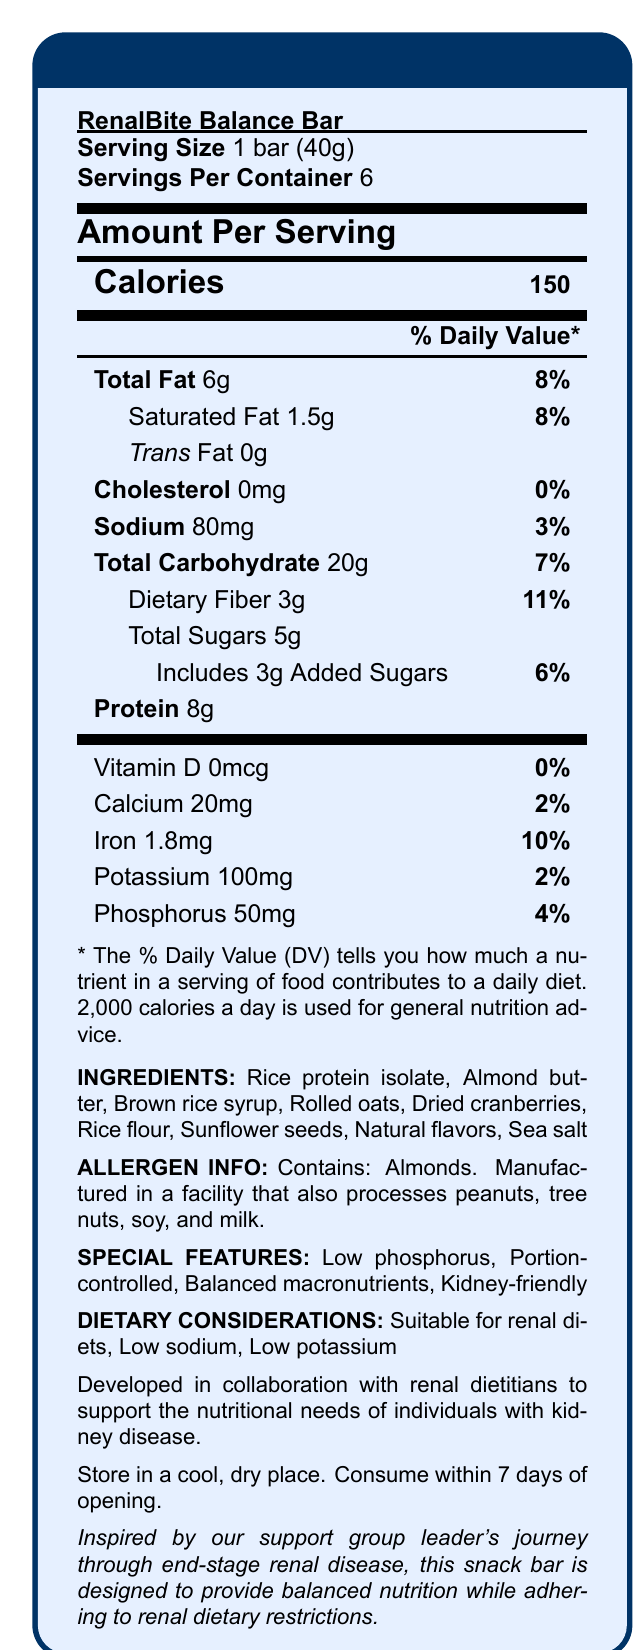what is the serving size of the RenalBite Balance Bar? The serving size is mentioned directly under the product name within the "Nutrition Facts" box.
Answer: 1 bar (40g) how many calories are in one serving of the RenalBite Balance Bar? The calories per serving are listed in bold under "Amount Per Serving."
Answer: 150 what percentage of the Daily Value is the total fat content in one serving? The Daily Value percentage for Total Fat is indicated alongside the amount of total fat.
Answer: 8% how much protein does one serving contain? The protein content is mentioned in the nutritional information section as "Protein 8g."
Answer: 8g which ingredient might cause an allergic reaction in someone with nut allergies? The Allergen Info section states the bar contains almonds.
Answer: Almonds how much sodium is present in one serving? The amount of sodium is listed in the nutrient table.
Answer: 80mg what is the source of dietary fiber in the ingredients list? A. Almond butter B. Rolled oats C. Dried cranberries D. Rice protein isolate While dietary fiber can come from multiple ingredients, rolled oats is a common high-fiber ingredient.
Answer: B. Rolled oats what is the daily value percentage of iron in one serving of the snack bar? A. 2% B. 10% C. 5% D. 15% The Daily Value percentage for iron is given as 10%.
Answer: B. 10% is the RenalBite Balance Bar suitable for renal diets? The document mentions that the bar is suitable for renal diets under "Dietary Considerations."
Answer: Yes does the product contain any trans fat? The amount of trans fat is listed as "Trans Fat 0g."
Answer: No / 0g summarize the main features of the RenalBite Balance Bar. The document details the nutritional content, ingredients, allergen information, and special features of the RenalBite Balance Bar, highlighting its suitability for renal diets.
Answer: The RenalBite Balance Bar is a snack specifically designed to support renal health. It is portion-controlled, low in phosphorus, sodium, and potassium, and provides balanced macronutrients. Developed in collaboration with renal dietitians, it aims to meet the dietary needs of individuals with kidney disease. what is the storage instruction for the RenalBite Balance Bar once opened? The storage instructions are listed at the end of the document.
Answer: Store in a cool, dry place. Consume within 7 days of opening. how many servings are there in one container of the snack bar? The number of servings per container is explicitly mentioned.
Answer: 6 does the RenalBite Balance Bar contain any vitamin D? The amount of vitamin D is given as 0mcg, which means the bar contains no vitamin D.
Answer: No what is the phosphorus content per serving? The phosphorus content is listed in the nutrient section as "Phosphorus 50mg."
Answer: 50mg who collaborated to develop the RenalBite Balance Bar? The manufacturer statement explicitly mentions the collaboration with renal dietitians.
Answer: Renal dietitians who inspired the development of the RenalBite Balance Bar? This is mentioned in the inspired-by statement at the end of the document.
Answer: The support group leader's journey through end-stage renal disease what is the primary protein source listed in the ingredients? The primary protein source mentioned is rice protein isolate.
Answer: Rice protein isolate are there any added sugars in the RenalBite Balance Bar? The document lists "3g Added Sugars" alongside the total sugars.
Answer: Yes, 3g can you determine the manufacturing facility's additional food processing details? The document states it is manufactured in a facility that processes peanuts, tree nuts, soy, and milk, but does not detail further manufacturing practices.
Answer: I don't know 